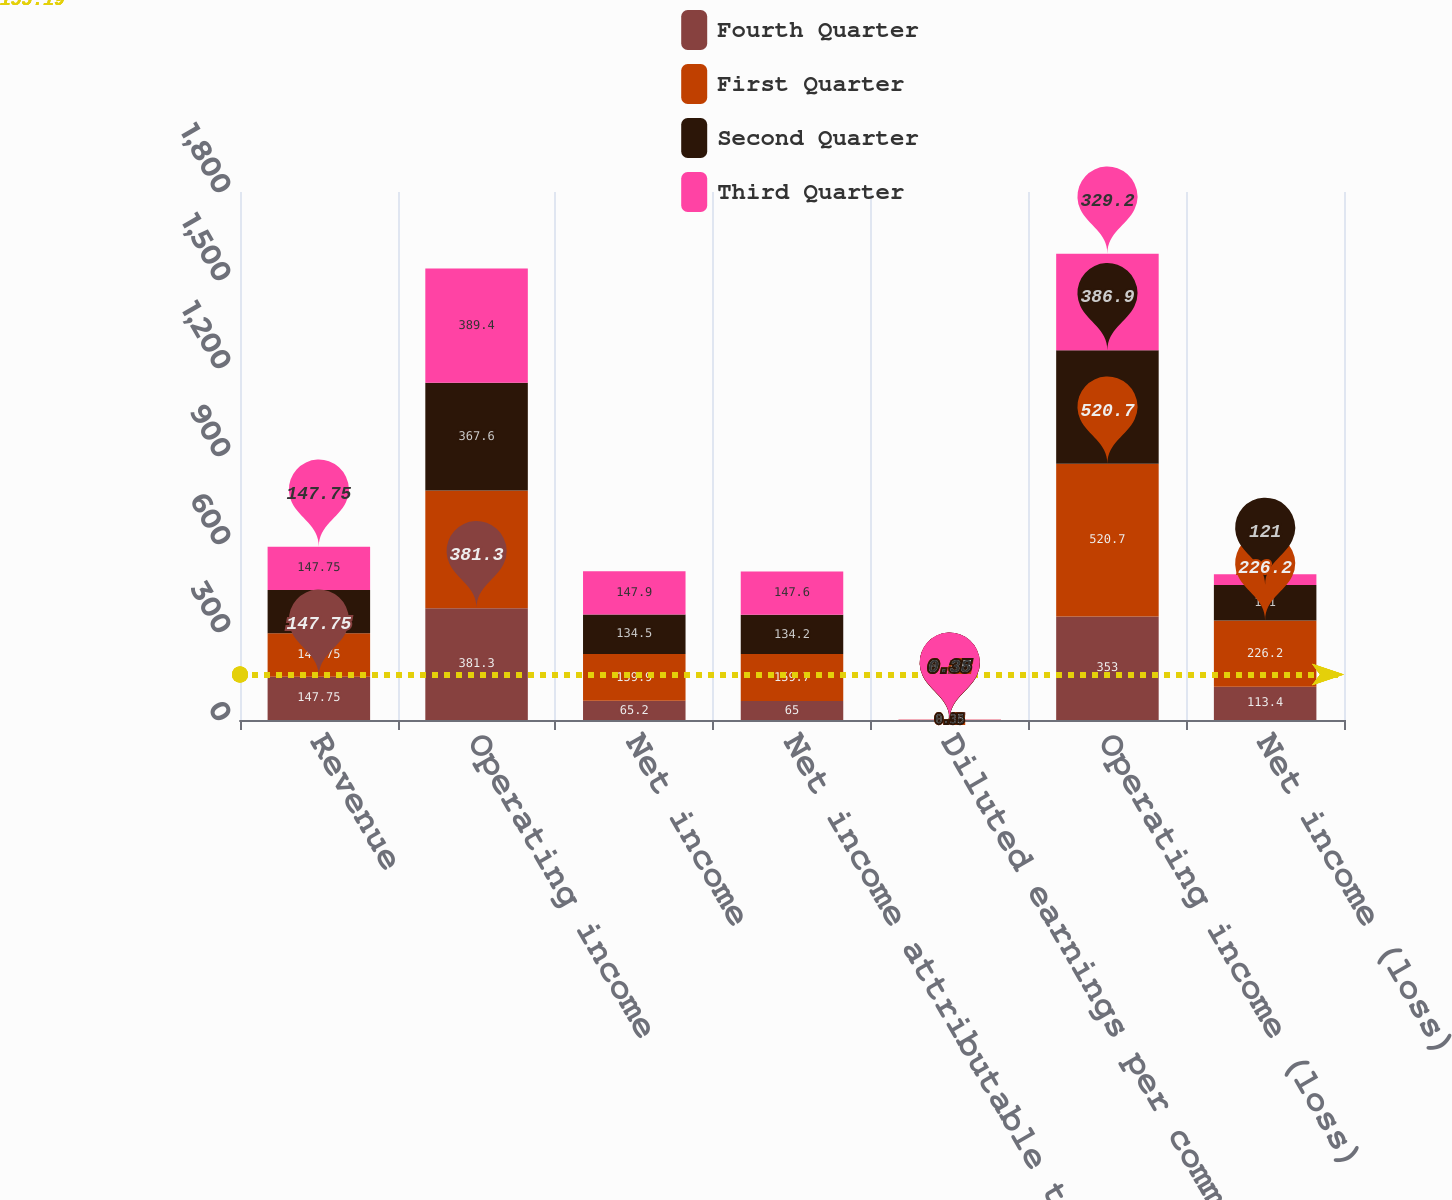<chart> <loc_0><loc_0><loc_500><loc_500><stacked_bar_chart><ecel><fcel>Revenue<fcel>Operating income<fcel>Net income<fcel>Net income attributable to<fcel>Diluted earnings per common<fcel>Operating income (loss)<fcel>Net income (loss)<nl><fcel>Fourth Quarter<fcel>147.75<fcel>381.3<fcel>65.2<fcel>65<fcel>0.17<fcel>353<fcel>113.4<nl><fcel>First Quarter<fcel>147.75<fcel>400.8<fcel>159.9<fcel>159.7<fcel>0.42<fcel>520.7<fcel>226.2<nl><fcel>Second Quarter<fcel>147.75<fcel>367.6<fcel>134.5<fcel>134.2<fcel>0.35<fcel>386.9<fcel>121<nl><fcel>Third Quarter<fcel>147.75<fcel>389.4<fcel>147.9<fcel>147.6<fcel>0.38<fcel>329.2<fcel>35.9<nl></chart> 